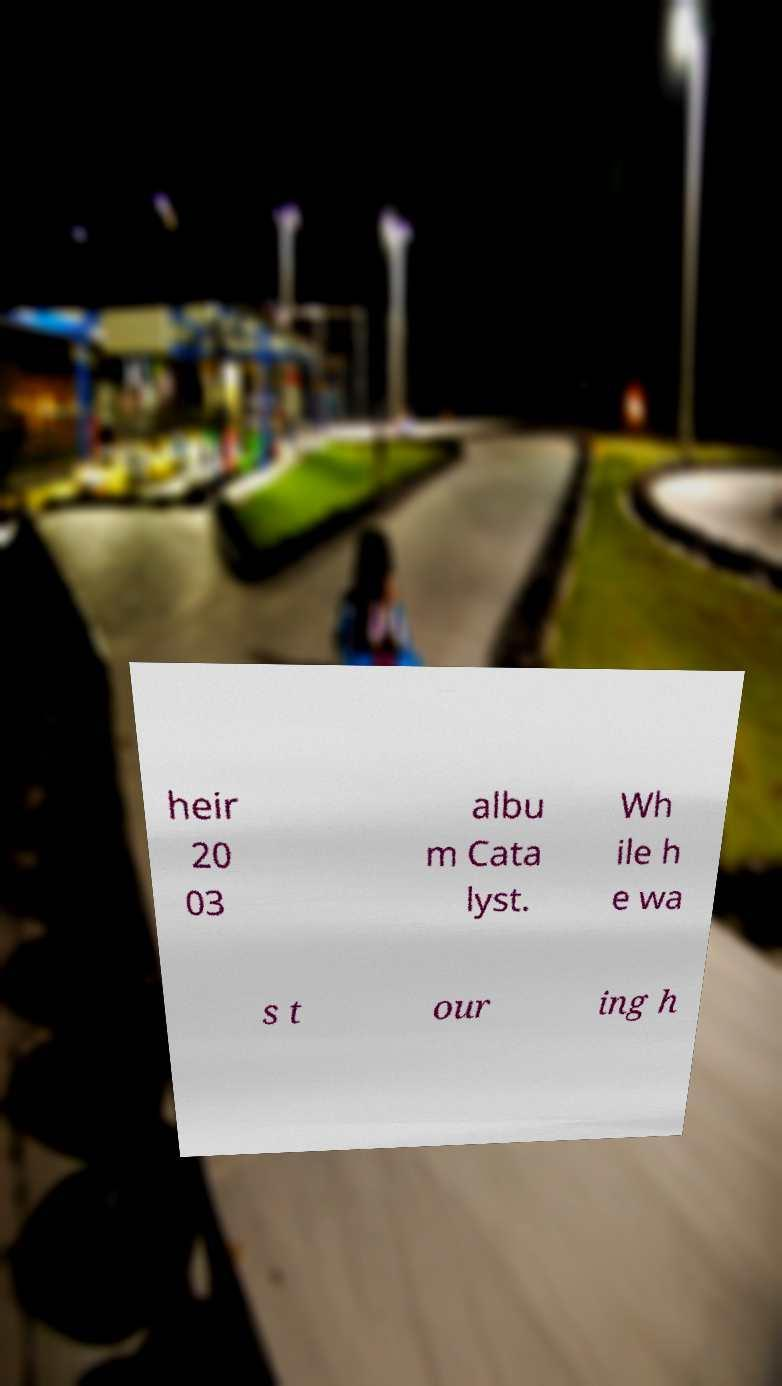Could you assist in decoding the text presented in this image and type it out clearly? heir 20 03 albu m Cata lyst. Wh ile h e wa s t our ing h 